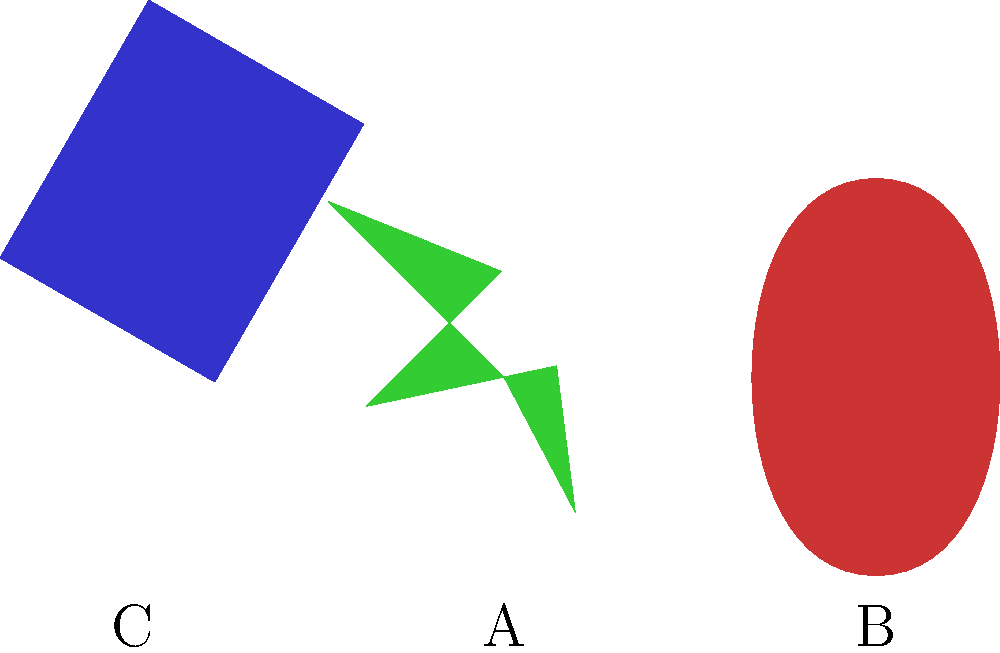Which of the symbols shown (A, B, or C) represents a book that has been rotated, and is commonly associated with family-friendly literature? To answer this question, we need to analyze each symbol and its transformation:

1. Symbol A (center): This is a green star shape that has been rotated 45 degrees clockwise. Stars are often used to represent ratings or excellence but are not specifically associated with literature.

2. Symbol B (right): This is a red heart shape that has been mirrored horizontally. Hearts typically represent love or affection but are not directly linked to literature.

3. Symbol C (left): This is a blue rectangular shape that has been rotated approximately 30 degrees counterclockwise. The rectangular shape with a slight opening on one side is a common representation of a book.

Given the context of family-friendly literature, the book symbol (C) is the most relevant. It has been rotated, which matches the description in the question. Books are fundamental to literature and are often used to represent reading, education, and family-friendly content.

Therefore, the symbol that represents a book and is commonly associated with family-friendly literature is C.
Answer: C 